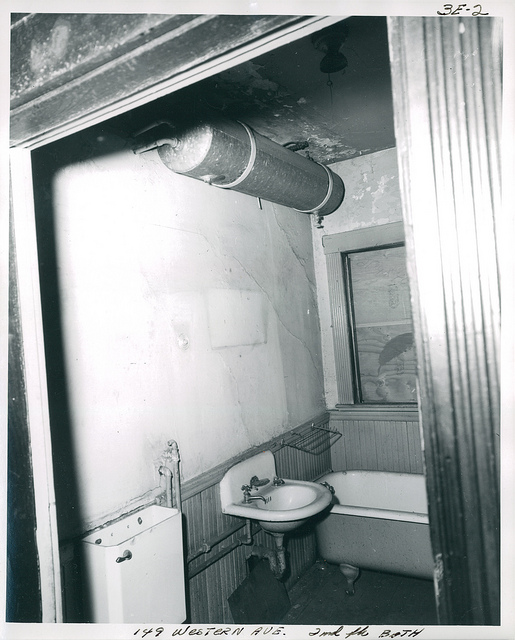How many sinks are there? There is one sink visible in the image, which is a typical finding in a small bathroom such as this. It has a classic design with a pedestal base, which fits nicely in the compact space offered by the room. 